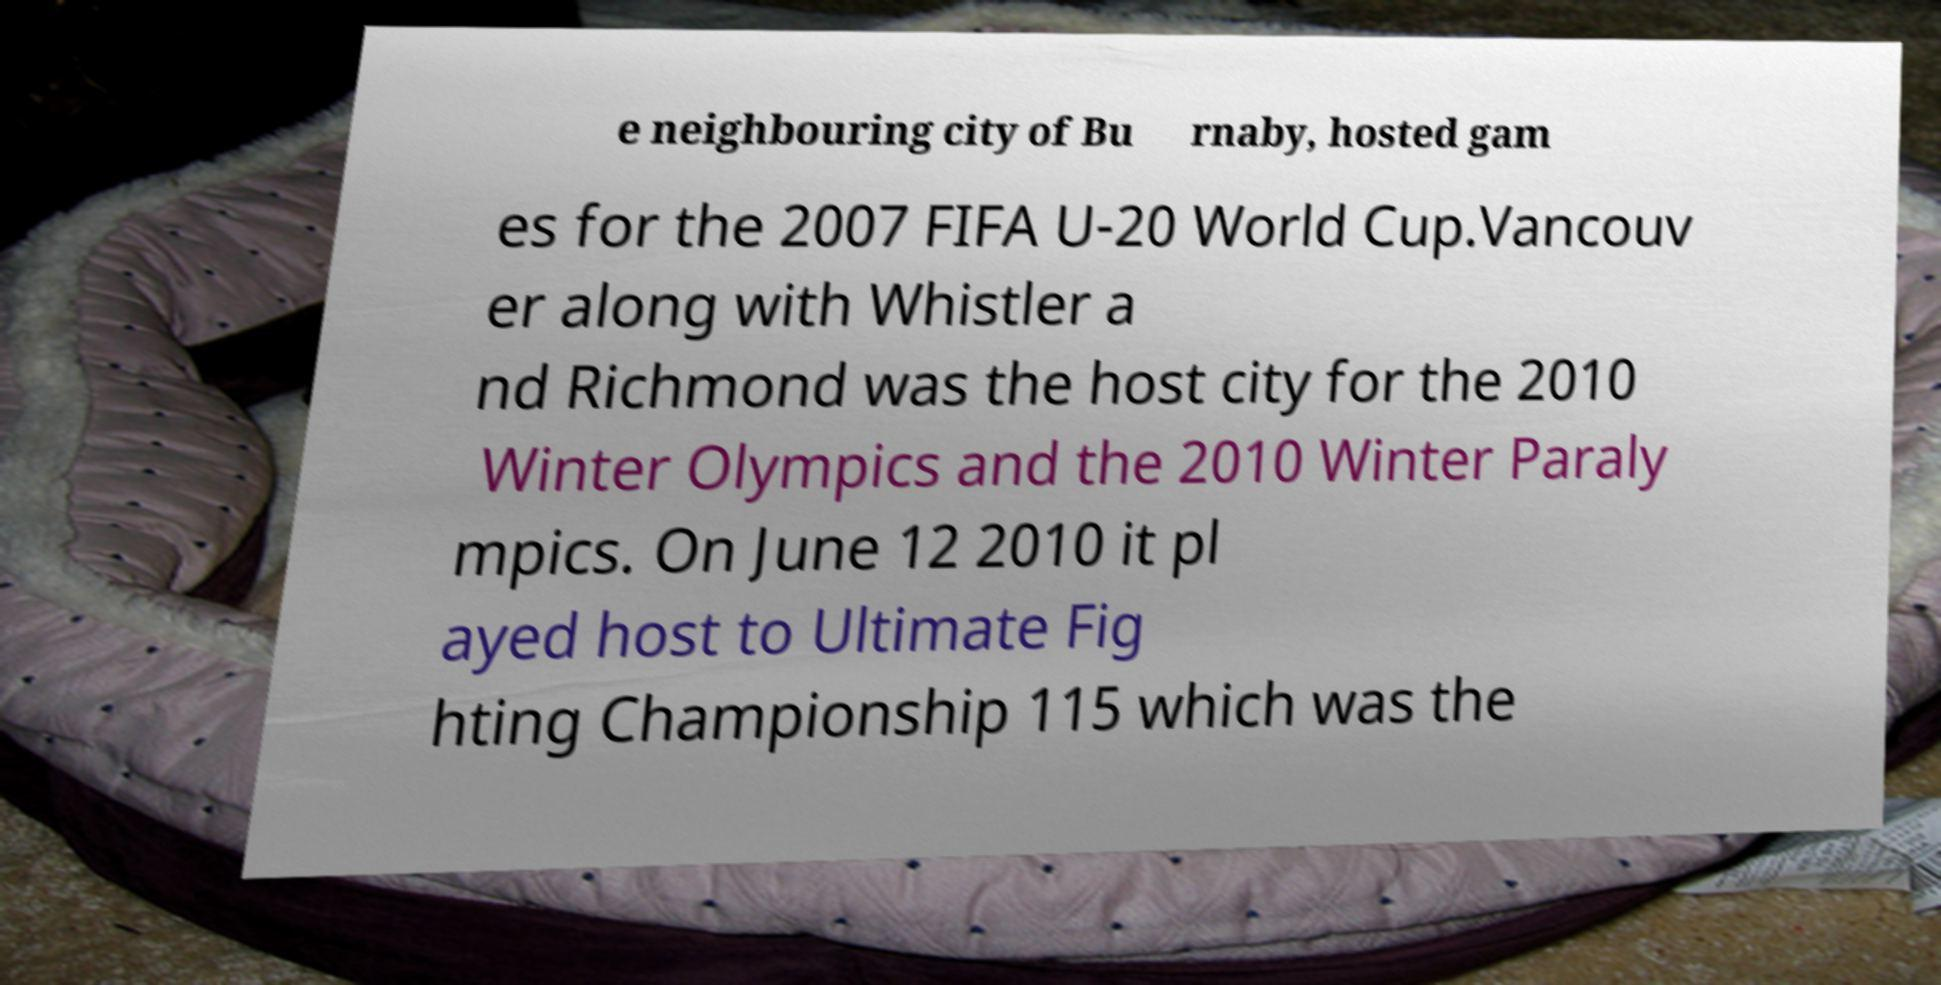There's text embedded in this image that I need extracted. Can you transcribe it verbatim? e neighbouring city of Bu rnaby, hosted gam es for the 2007 FIFA U-20 World Cup.Vancouv er along with Whistler a nd Richmond was the host city for the 2010 Winter Olympics and the 2010 Winter Paraly mpics. On June 12 2010 it pl ayed host to Ultimate Fig hting Championship 115 which was the 